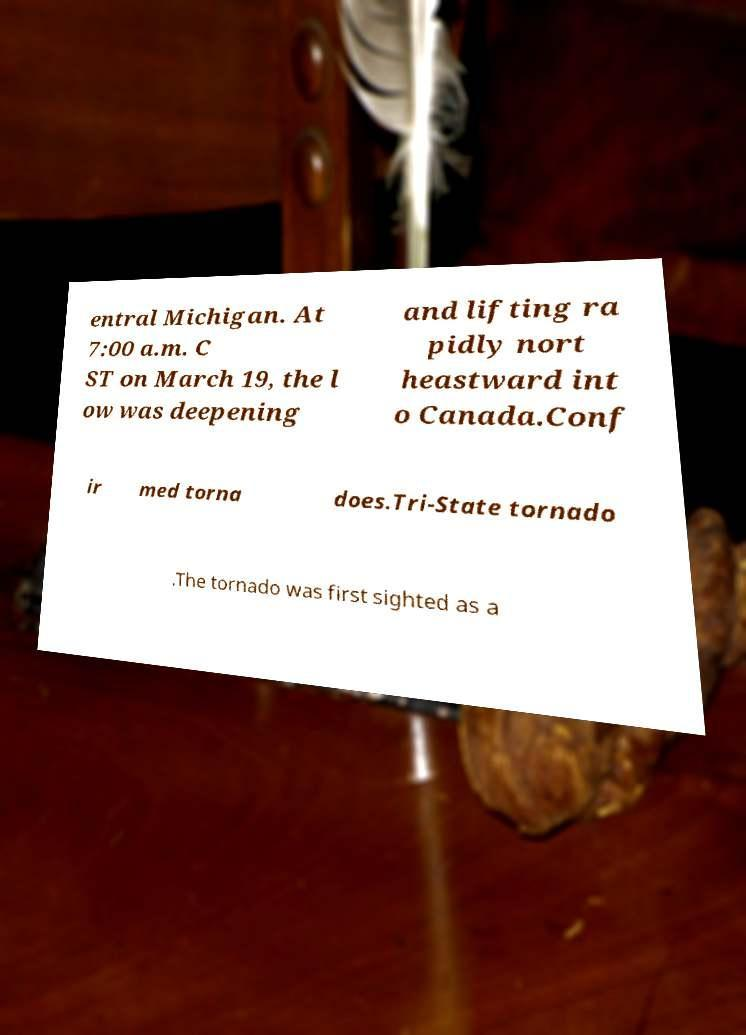There's text embedded in this image that I need extracted. Can you transcribe it verbatim? entral Michigan. At 7:00 a.m. C ST on March 19, the l ow was deepening and lifting ra pidly nort heastward int o Canada.Conf ir med torna does.Tri-State tornado .The tornado was first sighted as a 